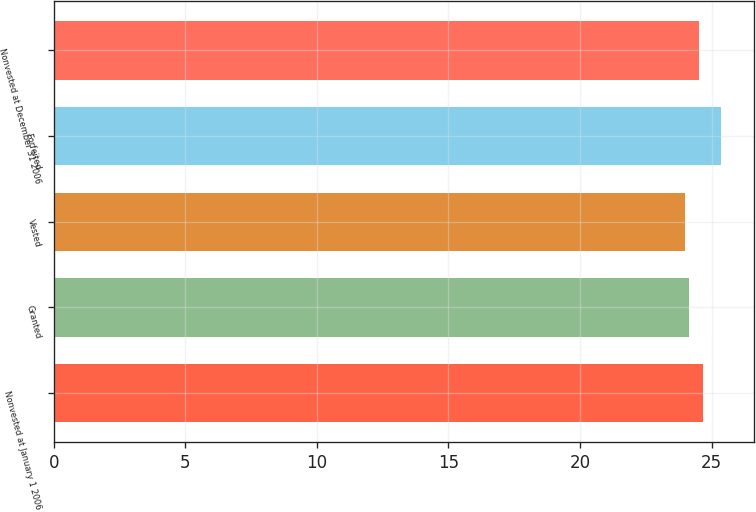Convert chart to OTSL. <chart><loc_0><loc_0><loc_500><loc_500><bar_chart><fcel>Nonvested at January 1 2006<fcel>Granted<fcel>Vested<fcel>Forfeited<fcel>Nonvested at December 31 2006<nl><fcel>24.67<fcel>24.13<fcel>23.99<fcel>25.36<fcel>24.51<nl></chart> 